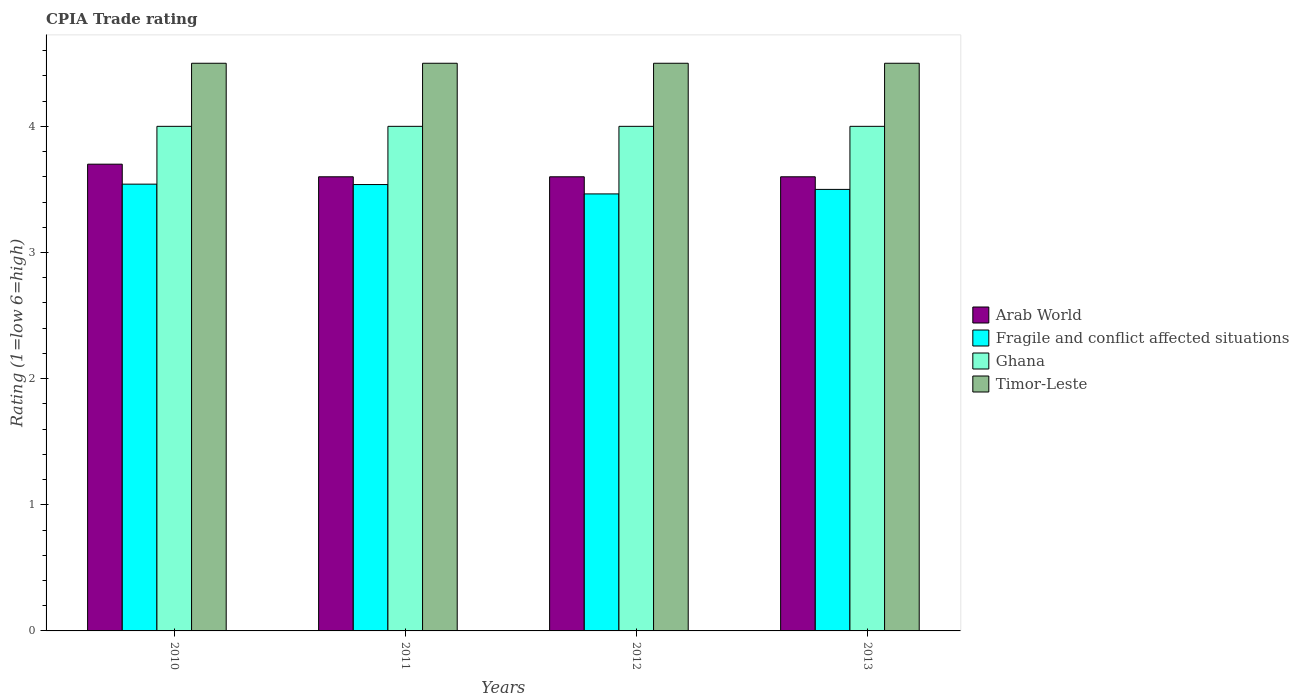Are the number of bars per tick equal to the number of legend labels?
Your response must be concise. Yes. How many bars are there on the 3rd tick from the left?
Give a very brief answer. 4. What is the label of the 3rd group of bars from the left?
Keep it short and to the point. 2012. In how many cases, is the number of bars for a given year not equal to the number of legend labels?
Your answer should be very brief. 0. What is the CPIA rating in Timor-Leste in 2010?
Make the answer very short. 4.5. Across all years, what is the minimum CPIA rating in Ghana?
Keep it short and to the point. 4. In which year was the CPIA rating in Fragile and conflict affected situations maximum?
Your response must be concise. 2010. In which year was the CPIA rating in Ghana minimum?
Ensure brevity in your answer.  2010. What is the total CPIA rating in Fragile and conflict affected situations in the graph?
Ensure brevity in your answer.  14.04. What is the difference between the CPIA rating in Timor-Leste in 2010 and that in 2013?
Give a very brief answer. 0. What is the difference between the CPIA rating in Fragile and conflict affected situations in 2011 and the CPIA rating in Arab World in 2013?
Provide a short and direct response. -0.06. What is the average CPIA rating in Fragile and conflict affected situations per year?
Provide a succinct answer. 3.51. In the year 2012, what is the difference between the CPIA rating in Arab World and CPIA rating in Fragile and conflict affected situations?
Provide a short and direct response. 0.14. What is the ratio of the CPIA rating in Timor-Leste in 2010 to that in 2011?
Your response must be concise. 1. What is the difference between the highest and the second highest CPIA rating in Arab World?
Your response must be concise. 0.1. What is the difference between the highest and the lowest CPIA rating in Arab World?
Your response must be concise. 0.1. In how many years, is the CPIA rating in Timor-Leste greater than the average CPIA rating in Timor-Leste taken over all years?
Ensure brevity in your answer.  0. Is the sum of the CPIA rating in Timor-Leste in 2010 and 2013 greater than the maximum CPIA rating in Ghana across all years?
Keep it short and to the point. Yes. Is it the case that in every year, the sum of the CPIA rating in Timor-Leste and CPIA rating in Fragile and conflict affected situations is greater than the sum of CPIA rating in Ghana and CPIA rating in Arab World?
Offer a terse response. Yes. What does the 4th bar from the left in 2010 represents?
Keep it short and to the point. Timor-Leste. What does the 4th bar from the right in 2010 represents?
Keep it short and to the point. Arab World. Is it the case that in every year, the sum of the CPIA rating in Fragile and conflict affected situations and CPIA rating in Arab World is greater than the CPIA rating in Timor-Leste?
Offer a very short reply. Yes. What is the difference between two consecutive major ticks on the Y-axis?
Give a very brief answer. 1. Are the values on the major ticks of Y-axis written in scientific E-notation?
Ensure brevity in your answer.  No. Where does the legend appear in the graph?
Your answer should be very brief. Center right. How many legend labels are there?
Provide a succinct answer. 4. How are the legend labels stacked?
Keep it short and to the point. Vertical. What is the title of the graph?
Make the answer very short. CPIA Trade rating. What is the Rating (1=low 6=high) in Arab World in 2010?
Offer a very short reply. 3.7. What is the Rating (1=low 6=high) in Fragile and conflict affected situations in 2010?
Make the answer very short. 3.54. What is the Rating (1=low 6=high) in Ghana in 2010?
Ensure brevity in your answer.  4. What is the Rating (1=low 6=high) of Fragile and conflict affected situations in 2011?
Your answer should be compact. 3.54. What is the Rating (1=low 6=high) of Ghana in 2011?
Give a very brief answer. 4. What is the Rating (1=low 6=high) in Timor-Leste in 2011?
Provide a short and direct response. 4.5. What is the Rating (1=low 6=high) of Fragile and conflict affected situations in 2012?
Provide a short and direct response. 3.46. What is the Rating (1=low 6=high) of Ghana in 2012?
Offer a terse response. 4. What is the Rating (1=low 6=high) of Timor-Leste in 2012?
Provide a short and direct response. 4.5. What is the Rating (1=low 6=high) of Arab World in 2013?
Provide a succinct answer. 3.6. What is the Rating (1=low 6=high) of Fragile and conflict affected situations in 2013?
Ensure brevity in your answer.  3.5. What is the Rating (1=low 6=high) in Ghana in 2013?
Provide a short and direct response. 4. Across all years, what is the maximum Rating (1=low 6=high) of Arab World?
Your response must be concise. 3.7. Across all years, what is the maximum Rating (1=low 6=high) in Fragile and conflict affected situations?
Offer a terse response. 3.54. Across all years, what is the maximum Rating (1=low 6=high) of Ghana?
Keep it short and to the point. 4. Across all years, what is the minimum Rating (1=low 6=high) in Arab World?
Your answer should be compact. 3.6. Across all years, what is the minimum Rating (1=low 6=high) in Fragile and conflict affected situations?
Your answer should be compact. 3.46. Across all years, what is the minimum Rating (1=low 6=high) in Ghana?
Make the answer very short. 4. What is the total Rating (1=low 6=high) in Arab World in the graph?
Your response must be concise. 14.5. What is the total Rating (1=low 6=high) of Fragile and conflict affected situations in the graph?
Offer a very short reply. 14.04. What is the total Rating (1=low 6=high) in Ghana in the graph?
Offer a terse response. 16. What is the difference between the Rating (1=low 6=high) of Arab World in 2010 and that in 2011?
Keep it short and to the point. 0.1. What is the difference between the Rating (1=low 6=high) of Fragile and conflict affected situations in 2010 and that in 2011?
Make the answer very short. 0. What is the difference between the Rating (1=low 6=high) of Fragile and conflict affected situations in 2010 and that in 2012?
Provide a succinct answer. 0.08. What is the difference between the Rating (1=low 6=high) in Ghana in 2010 and that in 2012?
Your response must be concise. 0. What is the difference between the Rating (1=low 6=high) in Arab World in 2010 and that in 2013?
Give a very brief answer. 0.1. What is the difference between the Rating (1=low 6=high) of Fragile and conflict affected situations in 2010 and that in 2013?
Make the answer very short. 0.04. What is the difference between the Rating (1=low 6=high) in Timor-Leste in 2010 and that in 2013?
Offer a terse response. 0. What is the difference between the Rating (1=low 6=high) of Fragile and conflict affected situations in 2011 and that in 2012?
Provide a short and direct response. 0.07. What is the difference between the Rating (1=low 6=high) in Ghana in 2011 and that in 2012?
Provide a short and direct response. 0. What is the difference between the Rating (1=low 6=high) of Timor-Leste in 2011 and that in 2012?
Ensure brevity in your answer.  0. What is the difference between the Rating (1=low 6=high) in Fragile and conflict affected situations in 2011 and that in 2013?
Ensure brevity in your answer.  0.04. What is the difference between the Rating (1=low 6=high) in Ghana in 2011 and that in 2013?
Your answer should be very brief. 0. What is the difference between the Rating (1=low 6=high) in Timor-Leste in 2011 and that in 2013?
Offer a terse response. 0. What is the difference between the Rating (1=low 6=high) in Fragile and conflict affected situations in 2012 and that in 2013?
Your answer should be compact. -0.04. What is the difference between the Rating (1=low 6=high) in Arab World in 2010 and the Rating (1=low 6=high) in Fragile and conflict affected situations in 2011?
Provide a succinct answer. 0.16. What is the difference between the Rating (1=low 6=high) of Fragile and conflict affected situations in 2010 and the Rating (1=low 6=high) of Ghana in 2011?
Keep it short and to the point. -0.46. What is the difference between the Rating (1=low 6=high) in Fragile and conflict affected situations in 2010 and the Rating (1=low 6=high) in Timor-Leste in 2011?
Offer a very short reply. -0.96. What is the difference between the Rating (1=low 6=high) in Ghana in 2010 and the Rating (1=low 6=high) in Timor-Leste in 2011?
Offer a terse response. -0.5. What is the difference between the Rating (1=low 6=high) in Arab World in 2010 and the Rating (1=low 6=high) in Fragile and conflict affected situations in 2012?
Keep it short and to the point. 0.24. What is the difference between the Rating (1=low 6=high) in Arab World in 2010 and the Rating (1=low 6=high) in Ghana in 2012?
Make the answer very short. -0.3. What is the difference between the Rating (1=low 6=high) of Arab World in 2010 and the Rating (1=low 6=high) of Timor-Leste in 2012?
Offer a very short reply. -0.8. What is the difference between the Rating (1=low 6=high) in Fragile and conflict affected situations in 2010 and the Rating (1=low 6=high) in Ghana in 2012?
Make the answer very short. -0.46. What is the difference between the Rating (1=low 6=high) in Fragile and conflict affected situations in 2010 and the Rating (1=low 6=high) in Timor-Leste in 2012?
Your answer should be compact. -0.96. What is the difference between the Rating (1=low 6=high) in Ghana in 2010 and the Rating (1=low 6=high) in Timor-Leste in 2012?
Offer a terse response. -0.5. What is the difference between the Rating (1=low 6=high) in Arab World in 2010 and the Rating (1=low 6=high) in Fragile and conflict affected situations in 2013?
Provide a succinct answer. 0.2. What is the difference between the Rating (1=low 6=high) in Arab World in 2010 and the Rating (1=low 6=high) in Ghana in 2013?
Keep it short and to the point. -0.3. What is the difference between the Rating (1=low 6=high) in Fragile and conflict affected situations in 2010 and the Rating (1=low 6=high) in Ghana in 2013?
Provide a succinct answer. -0.46. What is the difference between the Rating (1=low 6=high) in Fragile and conflict affected situations in 2010 and the Rating (1=low 6=high) in Timor-Leste in 2013?
Offer a very short reply. -0.96. What is the difference between the Rating (1=low 6=high) of Ghana in 2010 and the Rating (1=low 6=high) of Timor-Leste in 2013?
Provide a short and direct response. -0.5. What is the difference between the Rating (1=low 6=high) in Arab World in 2011 and the Rating (1=low 6=high) in Fragile and conflict affected situations in 2012?
Give a very brief answer. 0.14. What is the difference between the Rating (1=low 6=high) in Arab World in 2011 and the Rating (1=low 6=high) in Timor-Leste in 2012?
Keep it short and to the point. -0.9. What is the difference between the Rating (1=low 6=high) of Fragile and conflict affected situations in 2011 and the Rating (1=low 6=high) of Ghana in 2012?
Make the answer very short. -0.46. What is the difference between the Rating (1=low 6=high) of Fragile and conflict affected situations in 2011 and the Rating (1=low 6=high) of Timor-Leste in 2012?
Give a very brief answer. -0.96. What is the difference between the Rating (1=low 6=high) of Ghana in 2011 and the Rating (1=low 6=high) of Timor-Leste in 2012?
Provide a short and direct response. -0.5. What is the difference between the Rating (1=low 6=high) of Arab World in 2011 and the Rating (1=low 6=high) of Ghana in 2013?
Your answer should be very brief. -0.4. What is the difference between the Rating (1=low 6=high) of Fragile and conflict affected situations in 2011 and the Rating (1=low 6=high) of Ghana in 2013?
Offer a very short reply. -0.46. What is the difference between the Rating (1=low 6=high) of Fragile and conflict affected situations in 2011 and the Rating (1=low 6=high) of Timor-Leste in 2013?
Offer a very short reply. -0.96. What is the difference between the Rating (1=low 6=high) in Arab World in 2012 and the Rating (1=low 6=high) in Ghana in 2013?
Ensure brevity in your answer.  -0.4. What is the difference between the Rating (1=low 6=high) of Arab World in 2012 and the Rating (1=low 6=high) of Timor-Leste in 2013?
Your answer should be compact. -0.9. What is the difference between the Rating (1=low 6=high) in Fragile and conflict affected situations in 2012 and the Rating (1=low 6=high) in Ghana in 2013?
Offer a terse response. -0.54. What is the difference between the Rating (1=low 6=high) in Fragile and conflict affected situations in 2012 and the Rating (1=low 6=high) in Timor-Leste in 2013?
Provide a succinct answer. -1.04. What is the difference between the Rating (1=low 6=high) in Ghana in 2012 and the Rating (1=low 6=high) in Timor-Leste in 2013?
Ensure brevity in your answer.  -0.5. What is the average Rating (1=low 6=high) of Arab World per year?
Offer a terse response. 3.62. What is the average Rating (1=low 6=high) of Fragile and conflict affected situations per year?
Provide a succinct answer. 3.51. In the year 2010, what is the difference between the Rating (1=low 6=high) of Arab World and Rating (1=low 6=high) of Fragile and conflict affected situations?
Your answer should be compact. 0.16. In the year 2010, what is the difference between the Rating (1=low 6=high) of Arab World and Rating (1=low 6=high) of Timor-Leste?
Your response must be concise. -0.8. In the year 2010, what is the difference between the Rating (1=low 6=high) of Fragile and conflict affected situations and Rating (1=low 6=high) of Ghana?
Ensure brevity in your answer.  -0.46. In the year 2010, what is the difference between the Rating (1=low 6=high) in Fragile and conflict affected situations and Rating (1=low 6=high) in Timor-Leste?
Your answer should be very brief. -0.96. In the year 2011, what is the difference between the Rating (1=low 6=high) of Arab World and Rating (1=low 6=high) of Fragile and conflict affected situations?
Provide a short and direct response. 0.06. In the year 2011, what is the difference between the Rating (1=low 6=high) in Arab World and Rating (1=low 6=high) in Ghana?
Give a very brief answer. -0.4. In the year 2011, what is the difference between the Rating (1=low 6=high) in Fragile and conflict affected situations and Rating (1=low 6=high) in Ghana?
Ensure brevity in your answer.  -0.46. In the year 2011, what is the difference between the Rating (1=low 6=high) of Fragile and conflict affected situations and Rating (1=low 6=high) of Timor-Leste?
Make the answer very short. -0.96. In the year 2011, what is the difference between the Rating (1=low 6=high) in Ghana and Rating (1=low 6=high) in Timor-Leste?
Make the answer very short. -0.5. In the year 2012, what is the difference between the Rating (1=low 6=high) of Arab World and Rating (1=low 6=high) of Fragile and conflict affected situations?
Offer a very short reply. 0.14. In the year 2012, what is the difference between the Rating (1=low 6=high) of Arab World and Rating (1=low 6=high) of Ghana?
Your response must be concise. -0.4. In the year 2012, what is the difference between the Rating (1=low 6=high) in Arab World and Rating (1=low 6=high) in Timor-Leste?
Give a very brief answer. -0.9. In the year 2012, what is the difference between the Rating (1=low 6=high) in Fragile and conflict affected situations and Rating (1=low 6=high) in Ghana?
Keep it short and to the point. -0.54. In the year 2012, what is the difference between the Rating (1=low 6=high) of Fragile and conflict affected situations and Rating (1=low 6=high) of Timor-Leste?
Offer a terse response. -1.04. In the year 2012, what is the difference between the Rating (1=low 6=high) in Ghana and Rating (1=low 6=high) in Timor-Leste?
Your response must be concise. -0.5. In the year 2013, what is the difference between the Rating (1=low 6=high) of Arab World and Rating (1=low 6=high) of Fragile and conflict affected situations?
Your answer should be very brief. 0.1. In the year 2013, what is the difference between the Rating (1=low 6=high) in Arab World and Rating (1=low 6=high) in Timor-Leste?
Give a very brief answer. -0.9. In the year 2013, what is the difference between the Rating (1=low 6=high) in Ghana and Rating (1=low 6=high) in Timor-Leste?
Provide a succinct answer. -0.5. What is the ratio of the Rating (1=low 6=high) of Arab World in 2010 to that in 2011?
Provide a short and direct response. 1.03. What is the ratio of the Rating (1=low 6=high) in Timor-Leste in 2010 to that in 2011?
Provide a short and direct response. 1. What is the ratio of the Rating (1=low 6=high) in Arab World in 2010 to that in 2012?
Provide a succinct answer. 1.03. What is the ratio of the Rating (1=low 6=high) in Fragile and conflict affected situations in 2010 to that in 2012?
Give a very brief answer. 1.02. What is the ratio of the Rating (1=low 6=high) of Ghana in 2010 to that in 2012?
Your response must be concise. 1. What is the ratio of the Rating (1=low 6=high) in Timor-Leste in 2010 to that in 2012?
Your response must be concise. 1. What is the ratio of the Rating (1=low 6=high) in Arab World in 2010 to that in 2013?
Your answer should be compact. 1.03. What is the ratio of the Rating (1=low 6=high) in Fragile and conflict affected situations in 2010 to that in 2013?
Your answer should be very brief. 1.01. What is the ratio of the Rating (1=low 6=high) of Arab World in 2011 to that in 2012?
Make the answer very short. 1. What is the ratio of the Rating (1=low 6=high) of Fragile and conflict affected situations in 2011 to that in 2012?
Provide a succinct answer. 1.02. What is the ratio of the Rating (1=low 6=high) of Arab World in 2011 to that in 2013?
Provide a succinct answer. 1. What is the ratio of the Rating (1=low 6=high) in Fragile and conflict affected situations in 2011 to that in 2013?
Make the answer very short. 1.01. What is the difference between the highest and the second highest Rating (1=low 6=high) of Arab World?
Provide a short and direct response. 0.1. What is the difference between the highest and the second highest Rating (1=low 6=high) in Fragile and conflict affected situations?
Make the answer very short. 0. What is the difference between the highest and the lowest Rating (1=low 6=high) of Fragile and conflict affected situations?
Give a very brief answer. 0.08. 